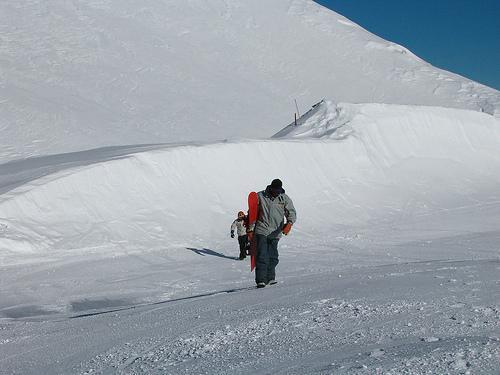How many people in the photo?
Give a very brief answer. 2. 